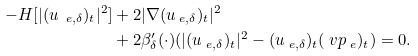<formula> <loc_0><loc_0><loc_500><loc_500>- H [ | ( u _ { \ e , \delta } ) _ { t } | ^ { 2 } ] & + 2 | \nabla ( u _ { \ e , \delta } ) _ { t } | ^ { 2 } \\ & + 2 \beta _ { \delta } ^ { \prime } ( \cdot ) ( | ( u _ { \ e , \delta } ) _ { t } | ^ { 2 } - ( u _ { \ e , \delta } ) _ { t } ( \ v p _ { \ e } ) _ { t } ) = 0 .</formula> 